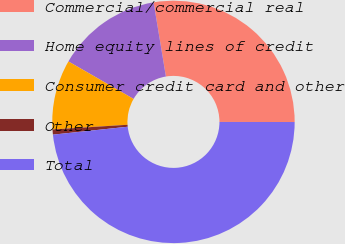Convert chart. <chart><loc_0><loc_0><loc_500><loc_500><pie_chart><fcel>Commercial/commercial real<fcel>Home equity lines of credit<fcel>Consumer credit card and other<fcel>Other<fcel>Total<nl><fcel>27.64%<fcel>14.07%<fcel>9.31%<fcel>0.68%<fcel>48.31%<nl></chart> 